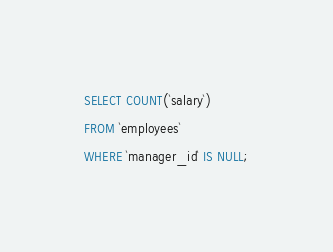<code> <loc_0><loc_0><loc_500><loc_500><_SQL_>SELECT COUNT(`salary`)
FROM `employees`
WHERE `manager_id` IS NULL;</code> 